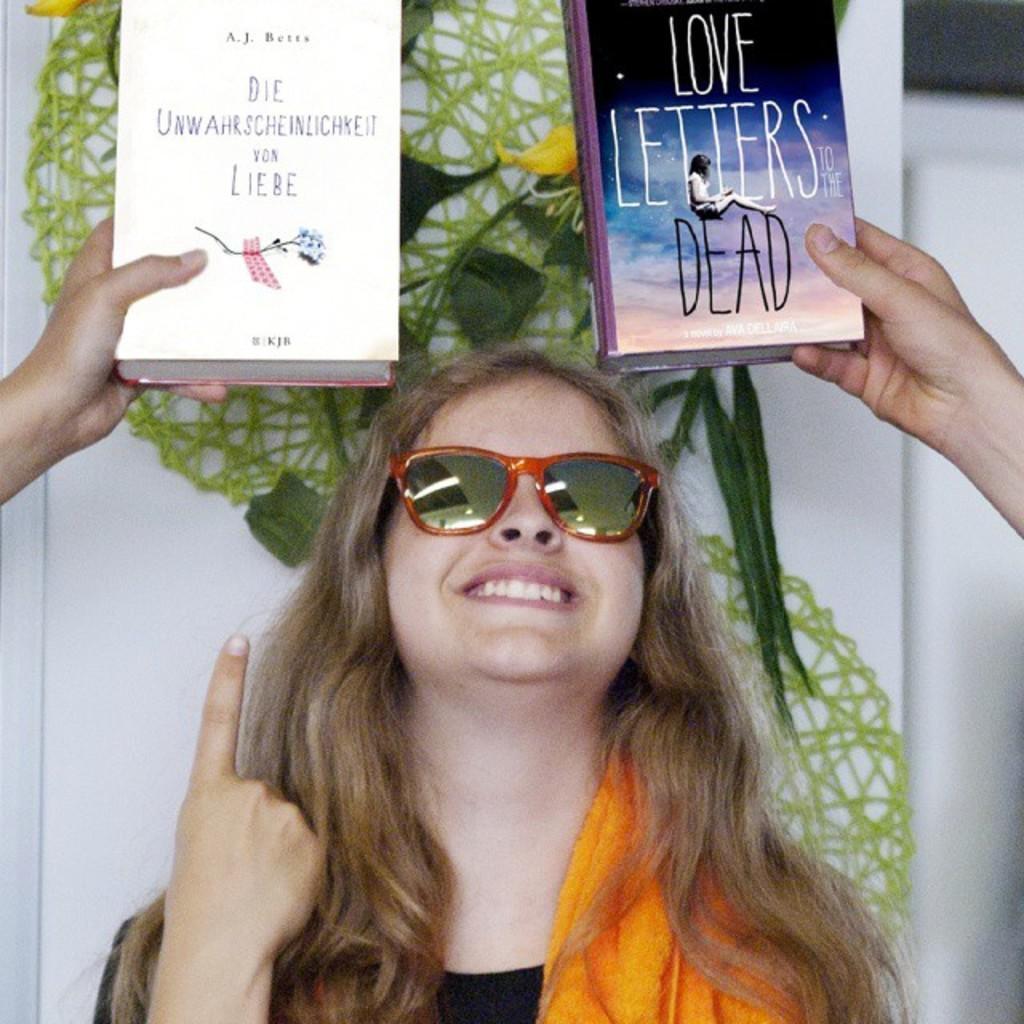Describe this image in one or two sentences. In the center of the image we can see a lady is smiling and wearing a dress, goggles. In the background of the image we can see the wall, decor, hands and books. 